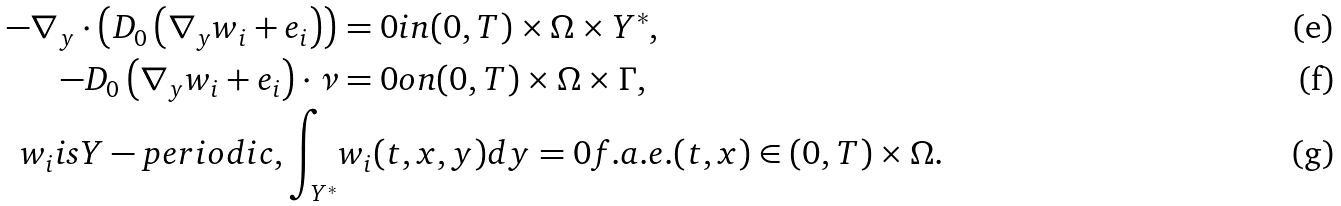<formula> <loc_0><loc_0><loc_500><loc_500>- \nabla _ { y } \cdot \left ( D _ { 0 } \left ( \nabla _ { y } w _ { i } + e _ { i } \right ) \right ) & = 0 i n ( 0 , T ) \times \Omega \times Y ^ { \ast } , \\ - D _ { 0 } \left ( \nabla _ { y } w _ { i } + e _ { i } \right ) \cdot \nu & = 0 o n ( 0 , T ) \times \Omega \times \Gamma , \\ w _ { i } i s Y - p e r i o d i c , \int _ { Y ^ { \ast } } & w _ { i } ( t , x , y ) d y = 0 f . a . e . ( t , x ) \in ( 0 , T ) \times \Omega .</formula> 